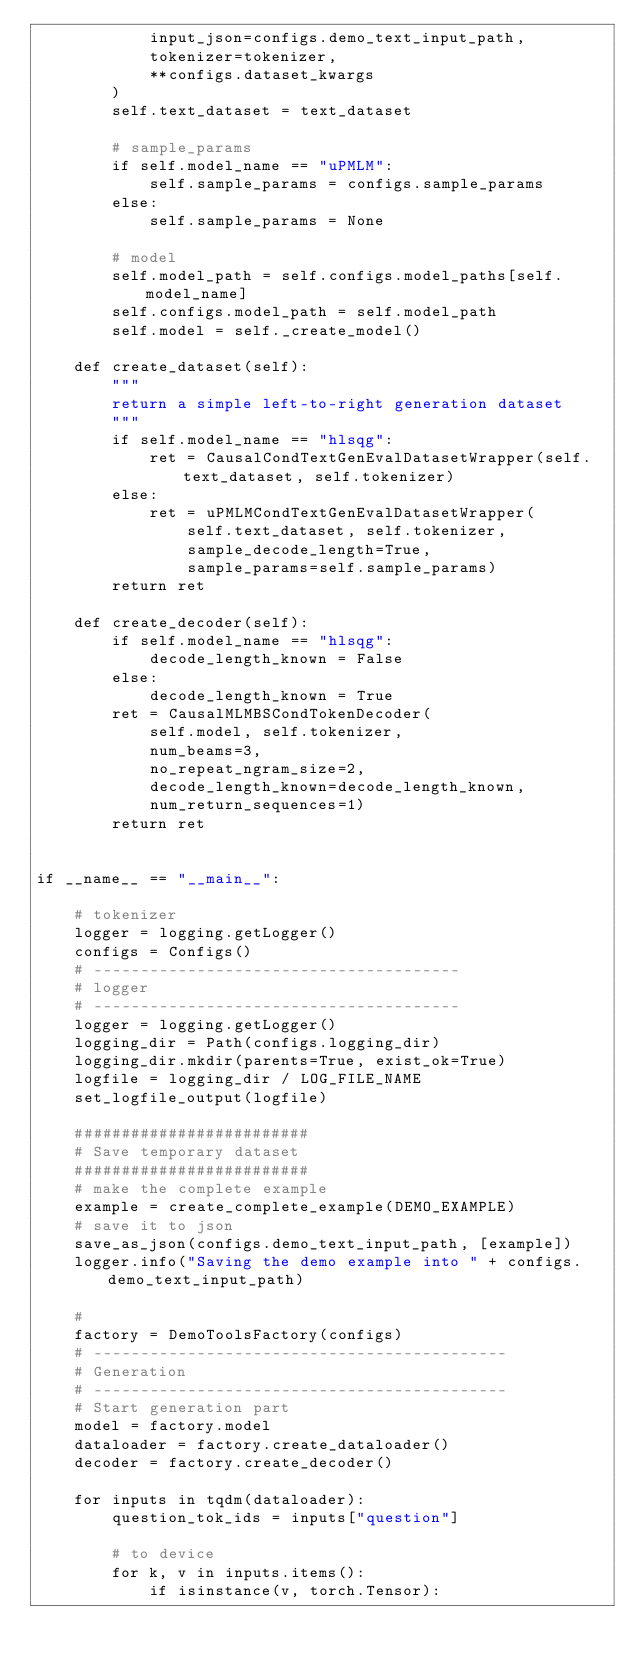Convert code to text. <code><loc_0><loc_0><loc_500><loc_500><_Python_>            input_json=configs.demo_text_input_path,
            tokenizer=tokenizer,
            **configs.dataset_kwargs
        )
        self.text_dataset = text_dataset

        # sample_params
        if self.model_name == "uPMLM":
            self.sample_params = configs.sample_params
        else:
            self.sample_params = None

        # model
        self.model_path = self.configs.model_paths[self.model_name]
        self.configs.model_path = self.model_path
        self.model = self._create_model()

    def create_dataset(self):
        """
        return a simple left-to-right generation dataset
        """
        if self.model_name == "hlsqg":
            ret = CausalCondTextGenEvalDatasetWrapper(self.text_dataset, self.tokenizer)
        else:
            ret = uPMLMCondTextGenEvalDatasetWrapper(
                self.text_dataset, self.tokenizer,
                sample_decode_length=True,
                sample_params=self.sample_params)
        return ret

    def create_decoder(self):
        if self.model_name == "hlsqg":
            decode_length_known = False
        else:
            decode_length_known = True
        ret = CausalMLMBSCondTokenDecoder(
            self.model, self.tokenizer,
            num_beams=3,
            no_repeat_ngram_size=2,
            decode_length_known=decode_length_known,
            num_return_sequences=1)
        return ret


if __name__ == "__main__":

    # tokenizer
    logger = logging.getLogger()
    configs = Configs()
    # ---------------------------------------
    # logger
    # ---------------------------------------
    logger = logging.getLogger()
    logging_dir = Path(configs.logging_dir)
    logging_dir.mkdir(parents=True, exist_ok=True)
    logfile = logging_dir / LOG_FILE_NAME
    set_logfile_output(logfile)

    #########################
    # Save temporary dataset
    #########################
    # make the complete example
    example = create_complete_example(DEMO_EXAMPLE)
    # save it to json
    save_as_json(configs.demo_text_input_path, [example])
    logger.info("Saving the demo example into " + configs.demo_text_input_path)

    #
    factory = DemoToolsFactory(configs)
    # --------------------------------------------
    # Generation
    # --------------------------------------------
    # Start generation part
    model = factory.model
    dataloader = factory.create_dataloader()
    decoder = factory.create_decoder()

    for inputs in tqdm(dataloader):
        question_tok_ids = inputs["question"]

        # to device
        for k, v in inputs.items():
            if isinstance(v, torch.Tensor):</code> 